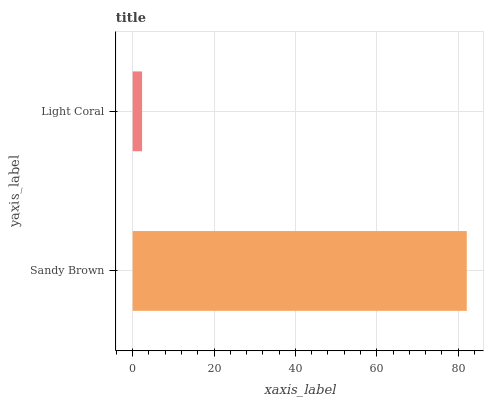Is Light Coral the minimum?
Answer yes or no. Yes. Is Sandy Brown the maximum?
Answer yes or no. Yes. Is Light Coral the maximum?
Answer yes or no. No. Is Sandy Brown greater than Light Coral?
Answer yes or no. Yes. Is Light Coral less than Sandy Brown?
Answer yes or no. Yes. Is Light Coral greater than Sandy Brown?
Answer yes or no. No. Is Sandy Brown less than Light Coral?
Answer yes or no. No. Is Sandy Brown the high median?
Answer yes or no. Yes. Is Light Coral the low median?
Answer yes or no. Yes. Is Light Coral the high median?
Answer yes or no. No. Is Sandy Brown the low median?
Answer yes or no. No. 